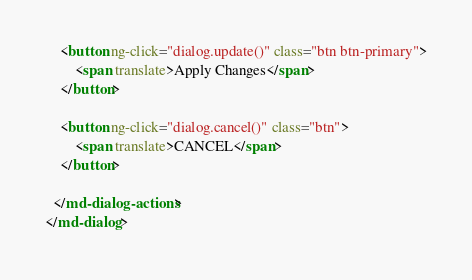Convert code to text. <code><loc_0><loc_0><loc_500><loc_500><_HTML_>
    <button ng-click="dialog.update()" class="btn btn-primary">
        <span translate>Apply Changes</span>
    </button>

    <button ng-click="dialog.cancel()" class="btn">
        <span translate>CANCEL</span>
    </button>

  </md-dialog-actions>
</md-dialog></code> 